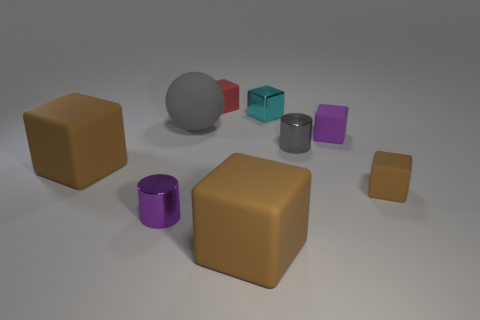The metal object that is both to the right of the tiny red thing and in front of the cyan shiny object has what shape?
Your answer should be very brief. Cylinder. There is a red thing that is the same shape as the small purple rubber object; what size is it?
Your answer should be very brief. Small. How many tiny cubes have the same material as the small red thing?
Provide a short and direct response. 2. There is a matte ball; does it have the same color as the small shiny cylinder that is to the right of the large gray sphere?
Offer a very short reply. Yes. Are there more small matte objects than big brown blocks?
Your answer should be compact. Yes. The tiny shiny block has what color?
Give a very brief answer. Cyan. There is a tiny metallic object right of the metallic cube; is its color the same as the sphere?
Ensure brevity in your answer.  Yes. What number of large rubber objects have the same color as the tiny metallic cube?
Make the answer very short. 0. Is the shape of the tiny cyan thing that is to the right of the red block the same as  the small brown rubber thing?
Your answer should be very brief. Yes. Are there fewer small purple metal cylinders on the right side of the large matte ball than large brown objects that are in front of the purple metallic thing?
Your answer should be compact. Yes. 